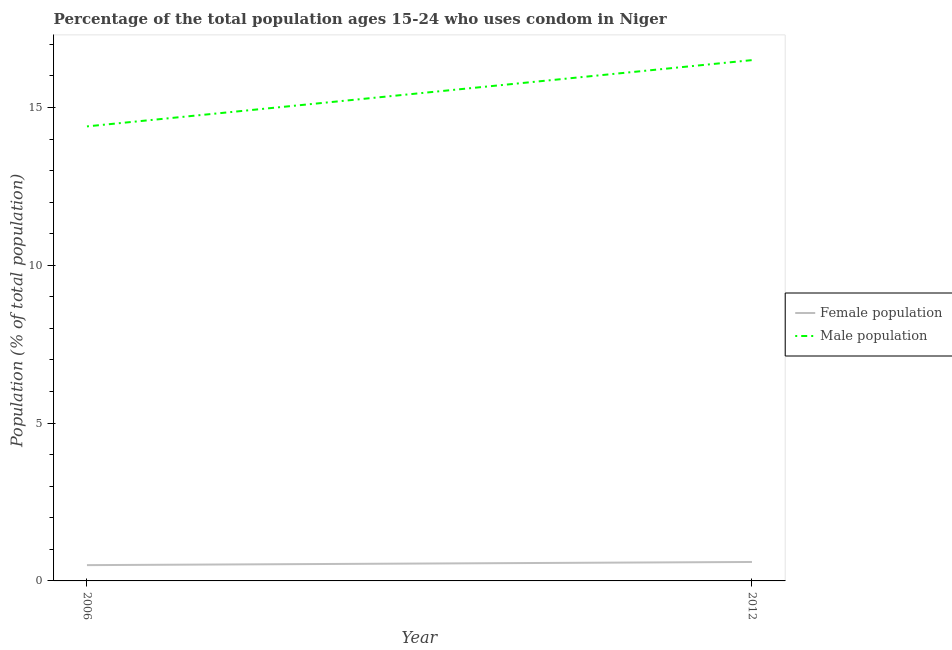How many different coloured lines are there?
Ensure brevity in your answer.  2. Does the line corresponding to male population intersect with the line corresponding to female population?
Provide a succinct answer. No. Is the number of lines equal to the number of legend labels?
Keep it short and to the point. Yes. What is the male population in 2012?
Give a very brief answer. 16.5. Across all years, what is the minimum male population?
Provide a succinct answer. 14.4. In which year was the female population maximum?
Your answer should be very brief. 2012. What is the total male population in the graph?
Ensure brevity in your answer.  30.9. What is the difference between the female population in 2006 and that in 2012?
Your response must be concise. -0.1. What is the average female population per year?
Ensure brevity in your answer.  0.55. In how many years, is the female population greater than 7 %?
Provide a succinct answer. 0. What is the ratio of the male population in 2006 to that in 2012?
Offer a very short reply. 0.87. Is the female population in 2006 less than that in 2012?
Keep it short and to the point. Yes. In how many years, is the female population greater than the average female population taken over all years?
Ensure brevity in your answer.  1. Does the female population monotonically increase over the years?
Ensure brevity in your answer.  Yes. Is the male population strictly greater than the female population over the years?
Make the answer very short. Yes. Is the female population strictly less than the male population over the years?
Give a very brief answer. Yes. How many years are there in the graph?
Your answer should be very brief. 2. Does the graph contain any zero values?
Your answer should be very brief. No. Where does the legend appear in the graph?
Offer a very short reply. Center right. How many legend labels are there?
Provide a short and direct response. 2. How are the legend labels stacked?
Your response must be concise. Vertical. What is the title of the graph?
Your answer should be very brief. Percentage of the total population ages 15-24 who uses condom in Niger. What is the label or title of the X-axis?
Your answer should be very brief. Year. What is the label or title of the Y-axis?
Give a very brief answer. Population (% of total population) . What is the Population (% of total population)  of Male population in 2006?
Your answer should be very brief. 14.4. What is the Population (% of total population)  of Male population in 2012?
Provide a succinct answer. 16.5. Across all years, what is the maximum Population (% of total population)  in Female population?
Your answer should be very brief. 0.6. What is the total Population (% of total population)  in Male population in the graph?
Keep it short and to the point. 30.9. What is the difference between the Population (% of total population)  of Male population in 2006 and that in 2012?
Your answer should be very brief. -2.1. What is the difference between the Population (% of total population)  in Female population in 2006 and the Population (% of total population)  in Male population in 2012?
Keep it short and to the point. -16. What is the average Population (% of total population)  in Female population per year?
Provide a succinct answer. 0.55. What is the average Population (% of total population)  of Male population per year?
Provide a succinct answer. 15.45. In the year 2006, what is the difference between the Population (% of total population)  in Female population and Population (% of total population)  in Male population?
Offer a very short reply. -13.9. In the year 2012, what is the difference between the Population (% of total population)  in Female population and Population (% of total population)  in Male population?
Provide a succinct answer. -15.9. What is the ratio of the Population (% of total population)  in Male population in 2006 to that in 2012?
Offer a terse response. 0.87. What is the difference between the highest and the lowest Population (% of total population)  of Female population?
Make the answer very short. 0.1. What is the difference between the highest and the lowest Population (% of total population)  of Male population?
Provide a short and direct response. 2.1. 